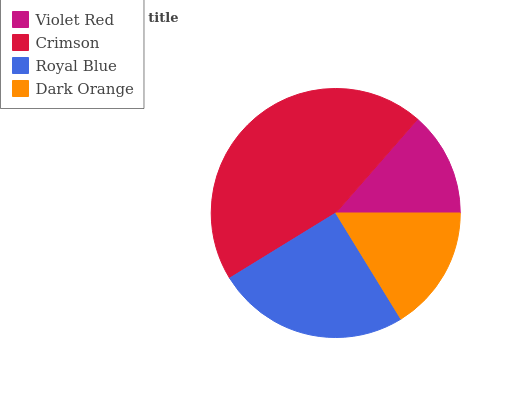Is Violet Red the minimum?
Answer yes or no. Yes. Is Crimson the maximum?
Answer yes or no. Yes. Is Royal Blue the minimum?
Answer yes or no. No. Is Royal Blue the maximum?
Answer yes or no. No. Is Crimson greater than Royal Blue?
Answer yes or no. Yes. Is Royal Blue less than Crimson?
Answer yes or no. Yes. Is Royal Blue greater than Crimson?
Answer yes or no. No. Is Crimson less than Royal Blue?
Answer yes or no. No. Is Royal Blue the high median?
Answer yes or no. Yes. Is Dark Orange the low median?
Answer yes or no. Yes. Is Violet Red the high median?
Answer yes or no. No. Is Royal Blue the low median?
Answer yes or no. No. 